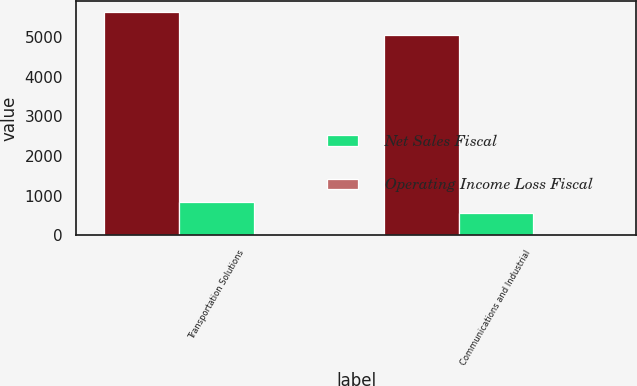<chart> <loc_0><loc_0><loc_500><loc_500><stacked_bar_chart><ecel><fcel>Transportation Solutions<fcel>Communications and Industrial<nl><fcel>nan<fcel>5629<fcel>5071<nl><fcel>Net Sales Fiscal<fcel>848<fcel>564<nl><fcel>Operating Income Loss Fiscal<fcel>1<fcel>1<nl></chart> 